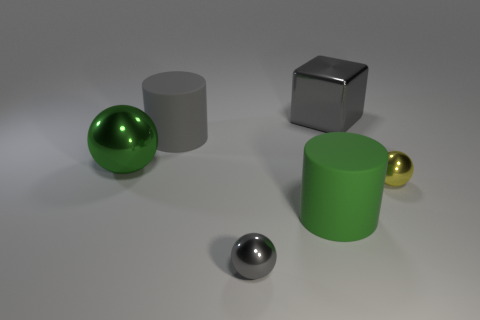Is there any other thing that has the same shape as the big gray shiny object?
Your response must be concise. No. There is a metallic sphere that is the same size as the gray block; what color is it?
Your answer should be very brief. Green. Is there a large gray block?
Offer a very short reply. Yes. There is a gray object that is in front of the small yellow metallic sphere; what is its shape?
Keep it short and to the point. Sphere. How many shiny objects are in front of the big gray cylinder and to the left of the yellow sphere?
Offer a very short reply. 2. Is there a green object made of the same material as the large green sphere?
Provide a short and direct response. No. What size is the cylinder that is the same color as the block?
Give a very brief answer. Large. How many balls are yellow matte objects or big gray metallic things?
Your response must be concise. 0. How big is the gray block?
Keep it short and to the point. Large. There is a green shiny sphere; how many green shiny objects are left of it?
Keep it short and to the point. 0. 